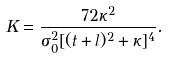<formula> <loc_0><loc_0><loc_500><loc_500>K = \frac { 7 2 \kappa ^ { 2 } } { \sigma _ { 0 } ^ { 2 } [ ( t + l ) ^ { 2 } + \kappa ] ^ { 4 } } .</formula> 